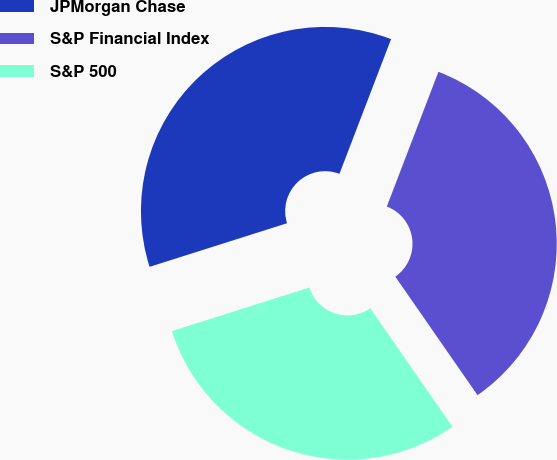<chart> <loc_0><loc_0><loc_500><loc_500><pie_chart><fcel>JPMorgan Chase<fcel>S&P Financial Index<fcel>S&P 500<nl><fcel>35.71%<fcel>34.52%<fcel>29.76%<nl></chart> 